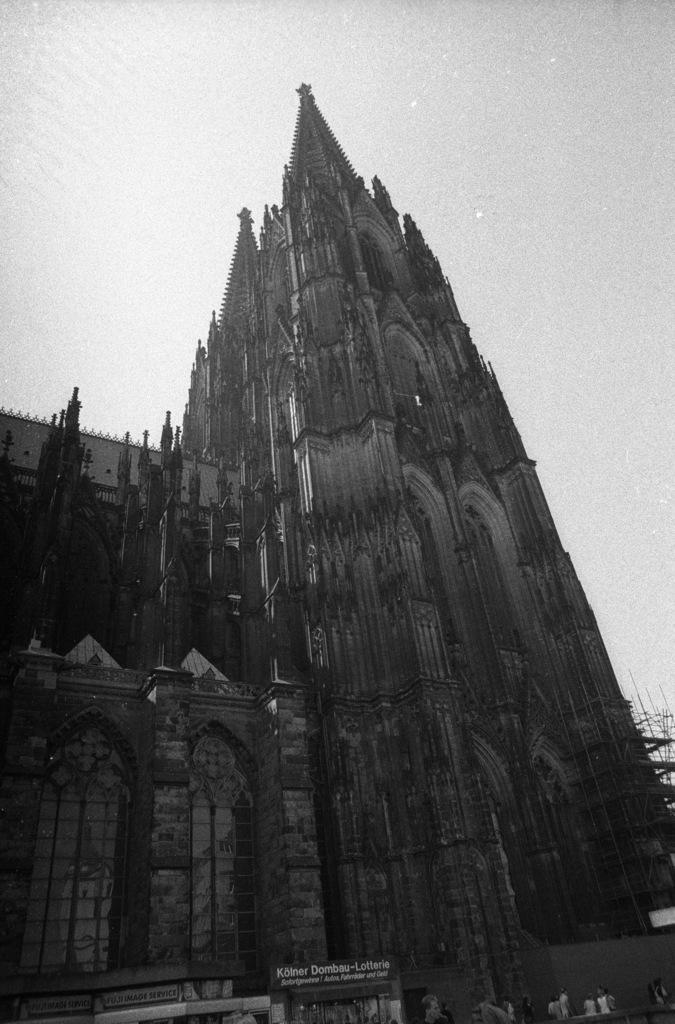Describe this image in one or two sentences. This picture consists of very old fort, at the top there is the sky. 